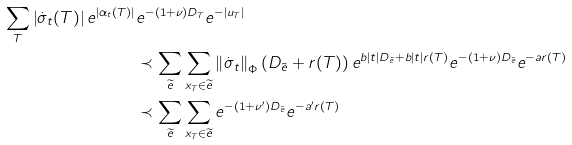Convert formula to latex. <formula><loc_0><loc_0><loc_500><loc_500>\sum _ { T } \left | \dot { \sigma } _ { t } ( T ) \right | e ^ { \left | \alpha _ { t } ( T ) \right | } & e ^ { - ( 1 + \nu ) D _ { T } } e ^ { - \left | u _ { T } \right | } \\ & \prec \sum _ { \widetilde { e } } \sum _ { x _ { T } \in \widetilde { e } } \left \| \dot { \sigma } _ { t } \right \| _ { \Phi } \left ( D _ { \tilde { e } } + r ( T ) \right ) e ^ { b \left | t \right | D _ { \tilde { e } } + b \left | t \right | r ( T ) } e ^ { - ( 1 + \nu ) D _ { \tilde { e } } } e ^ { - a r ( T ) } \\ & \prec \sum _ { \widetilde { e } } \sum _ { x _ { T } \in \widetilde { e } } e ^ { - ( 1 + \nu ^ { \prime } ) D _ { \tilde { e } } } e ^ { - a ^ { \prime } r ( T ) }</formula> 